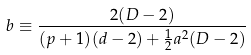Convert formula to latex. <formula><loc_0><loc_0><loc_500><loc_500>b \equiv \frac { 2 ( D - 2 ) } { ( p + 1 ) ( d - 2 ) + \frac { 1 } { 2 } a ^ { 2 } ( D - 2 ) }</formula> 